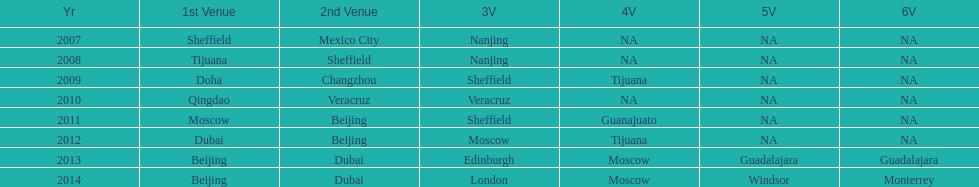Which year had more venues, 2007 or 2012? 2012. 